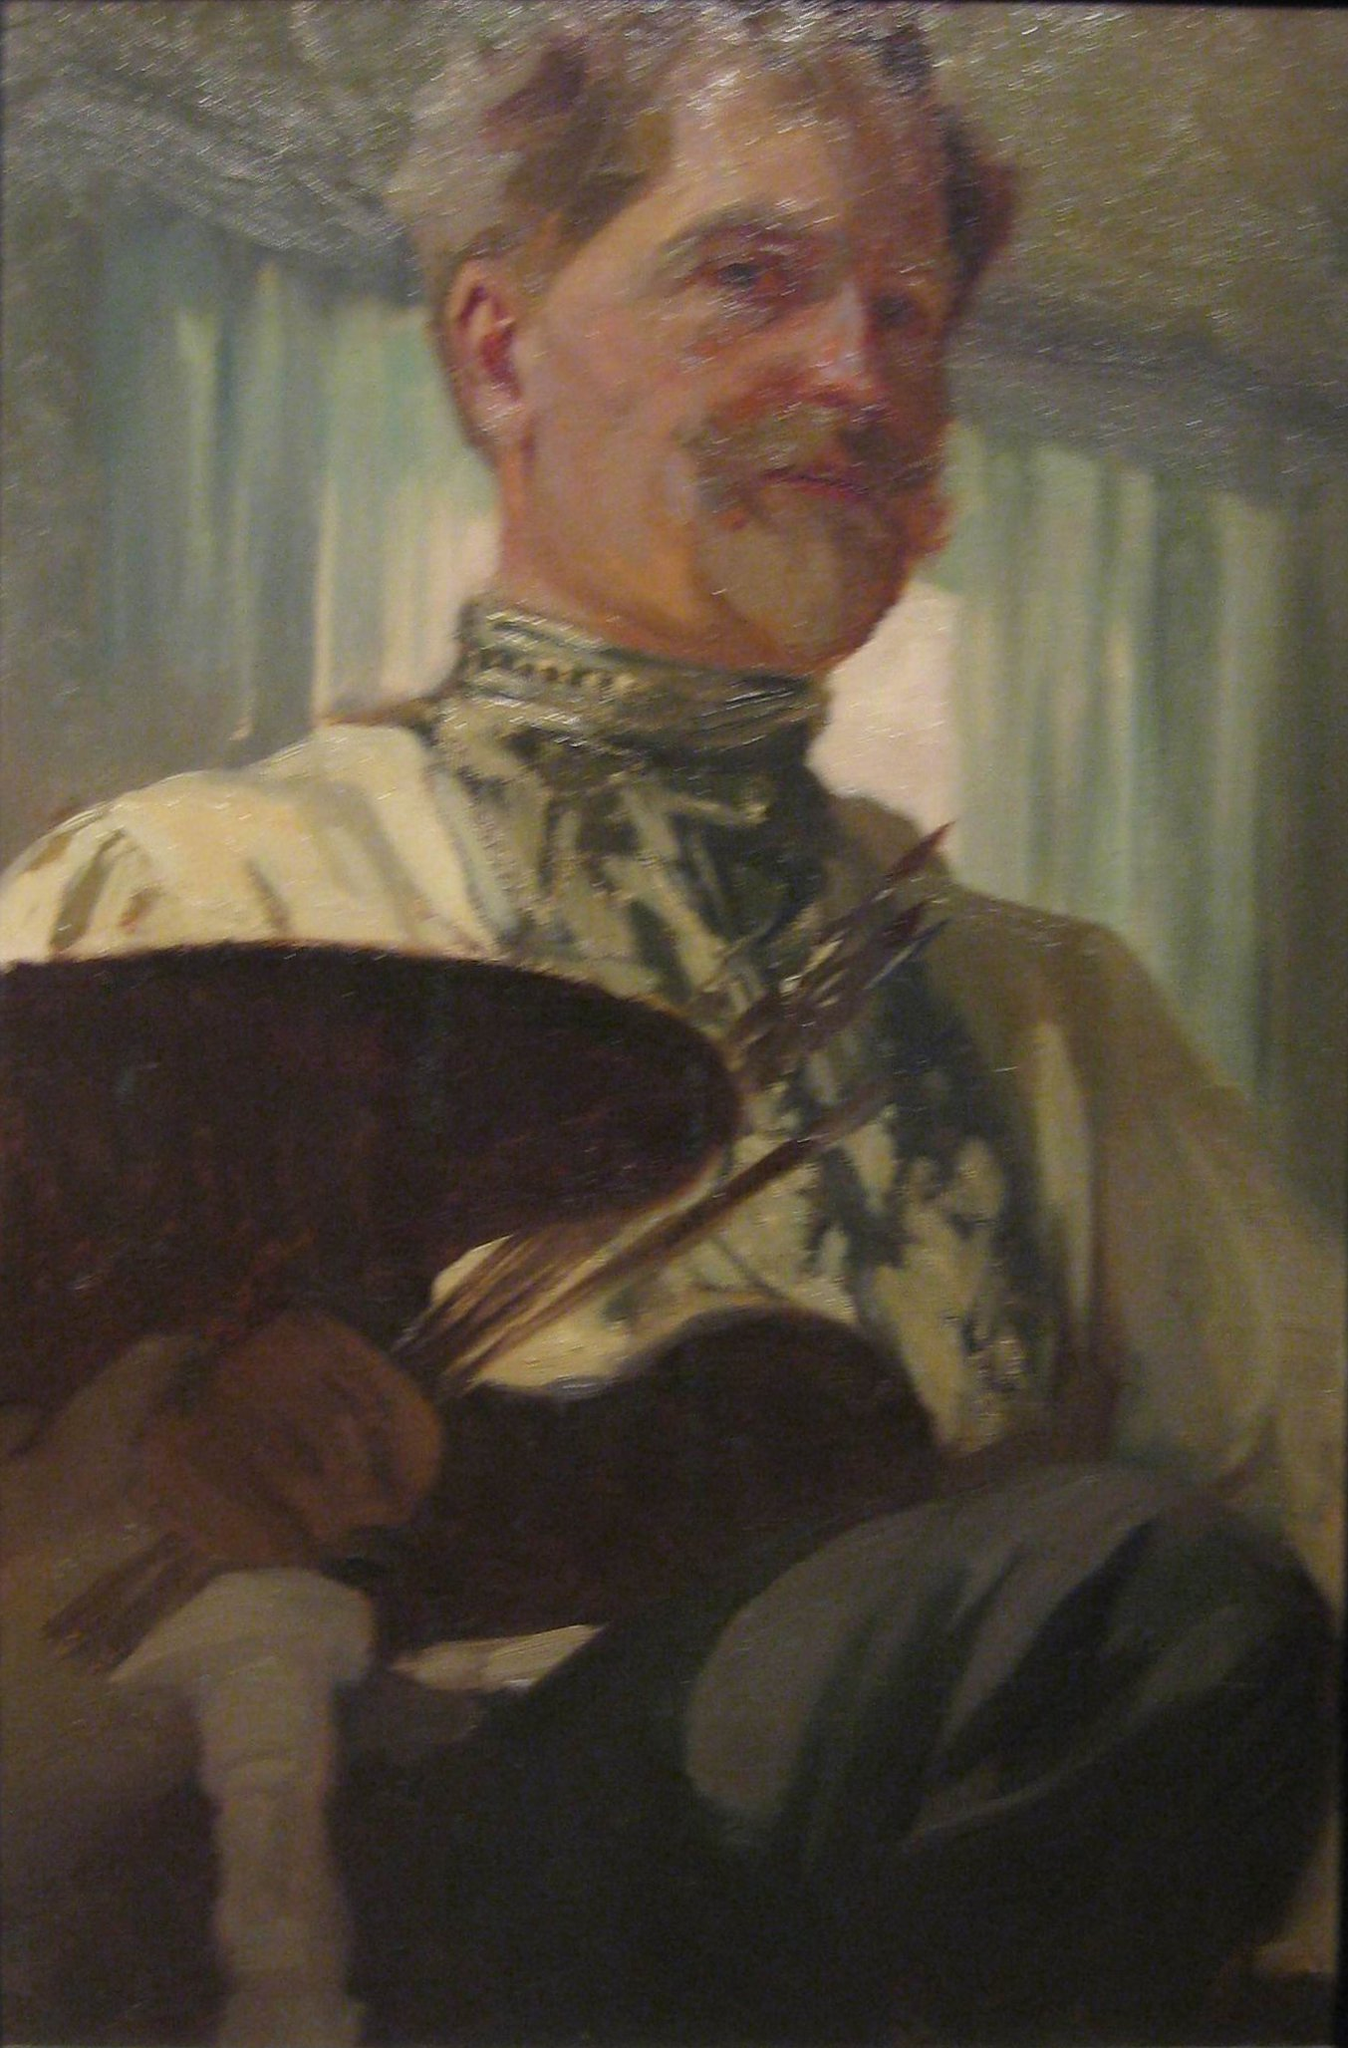How would you describe the lighting and its effects on the overall mood of the painting? The lighting in the painting is soft and diffused, creating gentle highlights and shadows that play across the subject’s face and clothing. This kind of lighting adds a sense of intimacy and warmth to the image, inviting viewers to feel close to the artist. The contrast between the softly lit figure and the muted background helps to emphasize the man's presence, making him the focal point of the painting. The subdued light subtly enhances the textures and depth, giving a lifelike quality to his skin and attire. Overall, the lighting contributes to an atmosphere of peaceful reflection, suggesting the quiet, thoughtful nature of the artist and his creative process. 